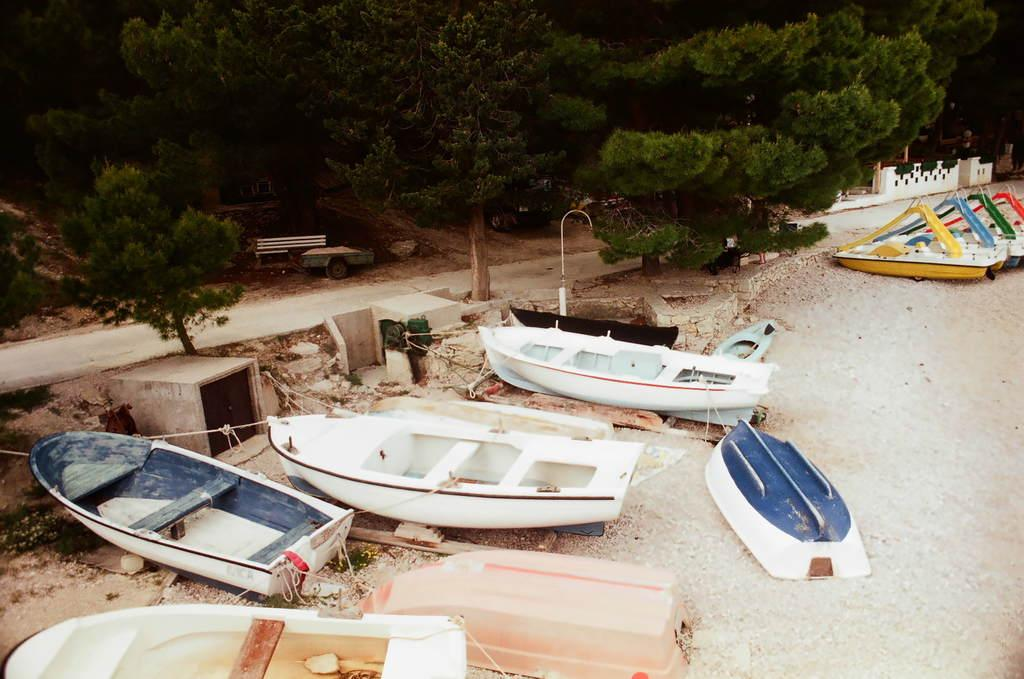What type of objects are on the ground in the image? There are boats on the ground in the image. What can be seen in the background of the image? There are trees visible at the top of the image. What other types of objects are present in the image? There are vehicles in the image. Is there any seating visible in the image? Yes, there is a bench in the image. What type of knee pain is the fowl experiencing in the image? There is no fowl present in the image, and therefore no information about any knee pain can be provided. 